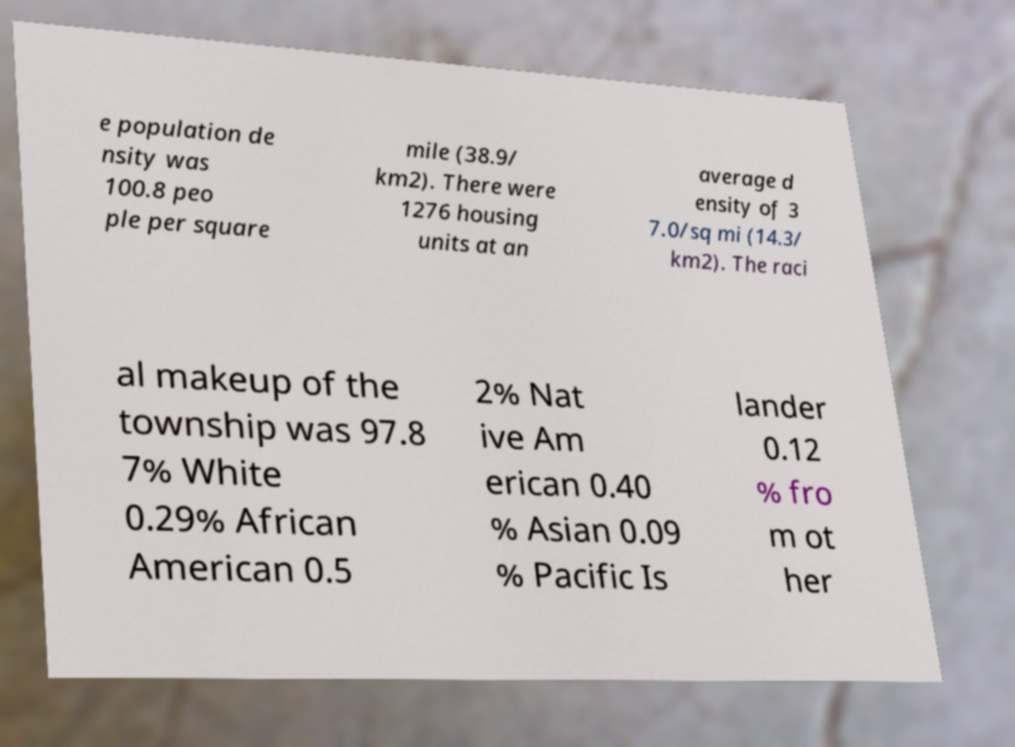Could you assist in decoding the text presented in this image and type it out clearly? e population de nsity was 100.8 peo ple per square mile (38.9/ km2). There were 1276 housing units at an average d ensity of 3 7.0/sq mi (14.3/ km2). The raci al makeup of the township was 97.8 7% White 0.29% African American 0.5 2% Nat ive Am erican 0.40 % Asian 0.09 % Pacific Is lander 0.12 % fro m ot her 